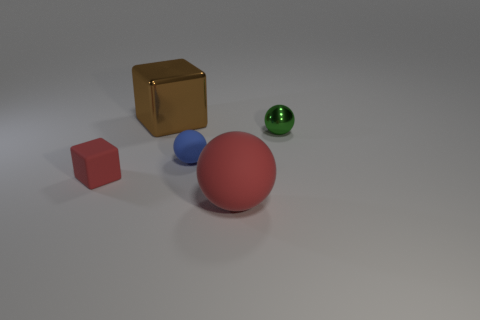What material is the red object in front of the red object to the left of the blue matte ball made of?
Provide a succinct answer. Rubber. Are there fewer shiny spheres to the right of the green shiny thing than blue matte objects?
Make the answer very short. Yes. There is a red object right of the brown metal cube; what is its shape?
Your response must be concise. Sphere. Do the green thing and the cube in front of the small green metallic object have the same size?
Provide a short and direct response. Yes. Are there any small cubes made of the same material as the big ball?
Your answer should be compact. Yes. What number of cylinders are either small things or tiny blue objects?
Provide a succinct answer. 0. There is a big thing behind the small red matte cube; is there a tiny object that is left of it?
Your response must be concise. Yes. Is the number of tiny brown metallic things less than the number of big red rubber balls?
Ensure brevity in your answer.  Yes. How many brown objects are the same shape as the small green object?
Your response must be concise. 0. How many blue objects are big metal blocks or spheres?
Your answer should be compact. 1. 